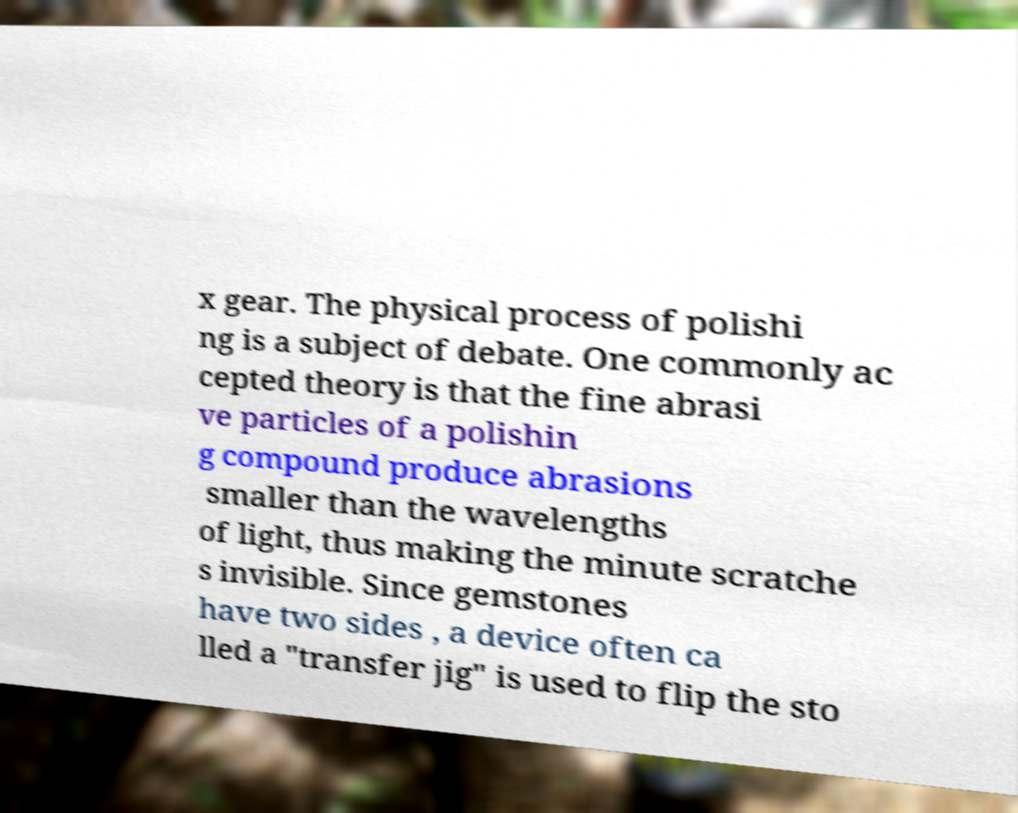What messages or text are displayed in this image? I need them in a readable, typed format. x gear. The physical process of polishi ng is a subject of debate. One commonly ac cepted theory is that the fine abrasi ve particles of a polishin g compound produce abrasions smaller than the wavelengths of light, thus making the minute scratche s invisible. Since gemstones have two sides , a device often ca lled a "transfer jig" is used to flip the sto 